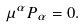<formula> <loc_0><loc_0><loc_500><loc_500>\mu ^ { \alpha } P _ { \alpha } = 0 .</formula> 